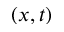<formula> <loc_0><loc_0><loc_500><loc_500>( x , t )</formula> 